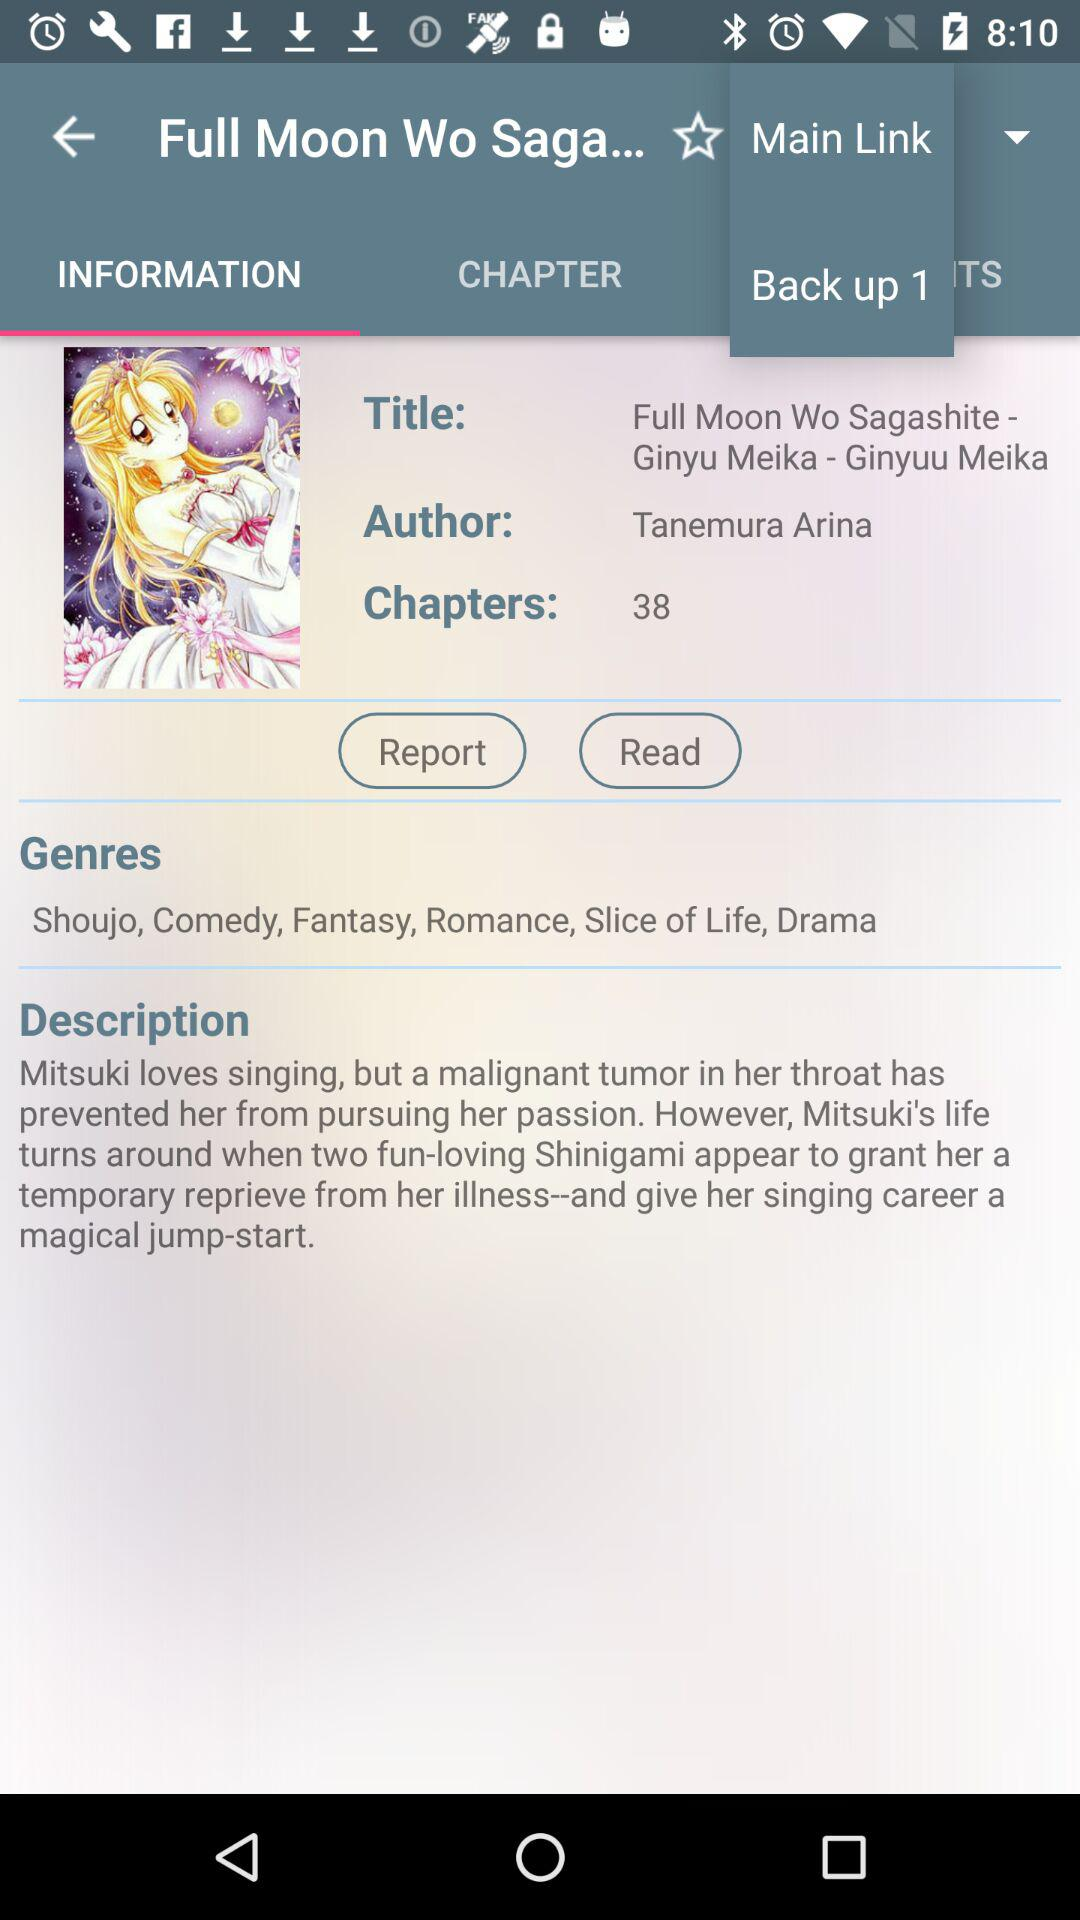How many chapters are in the book? There are 38 chapters in the book. 